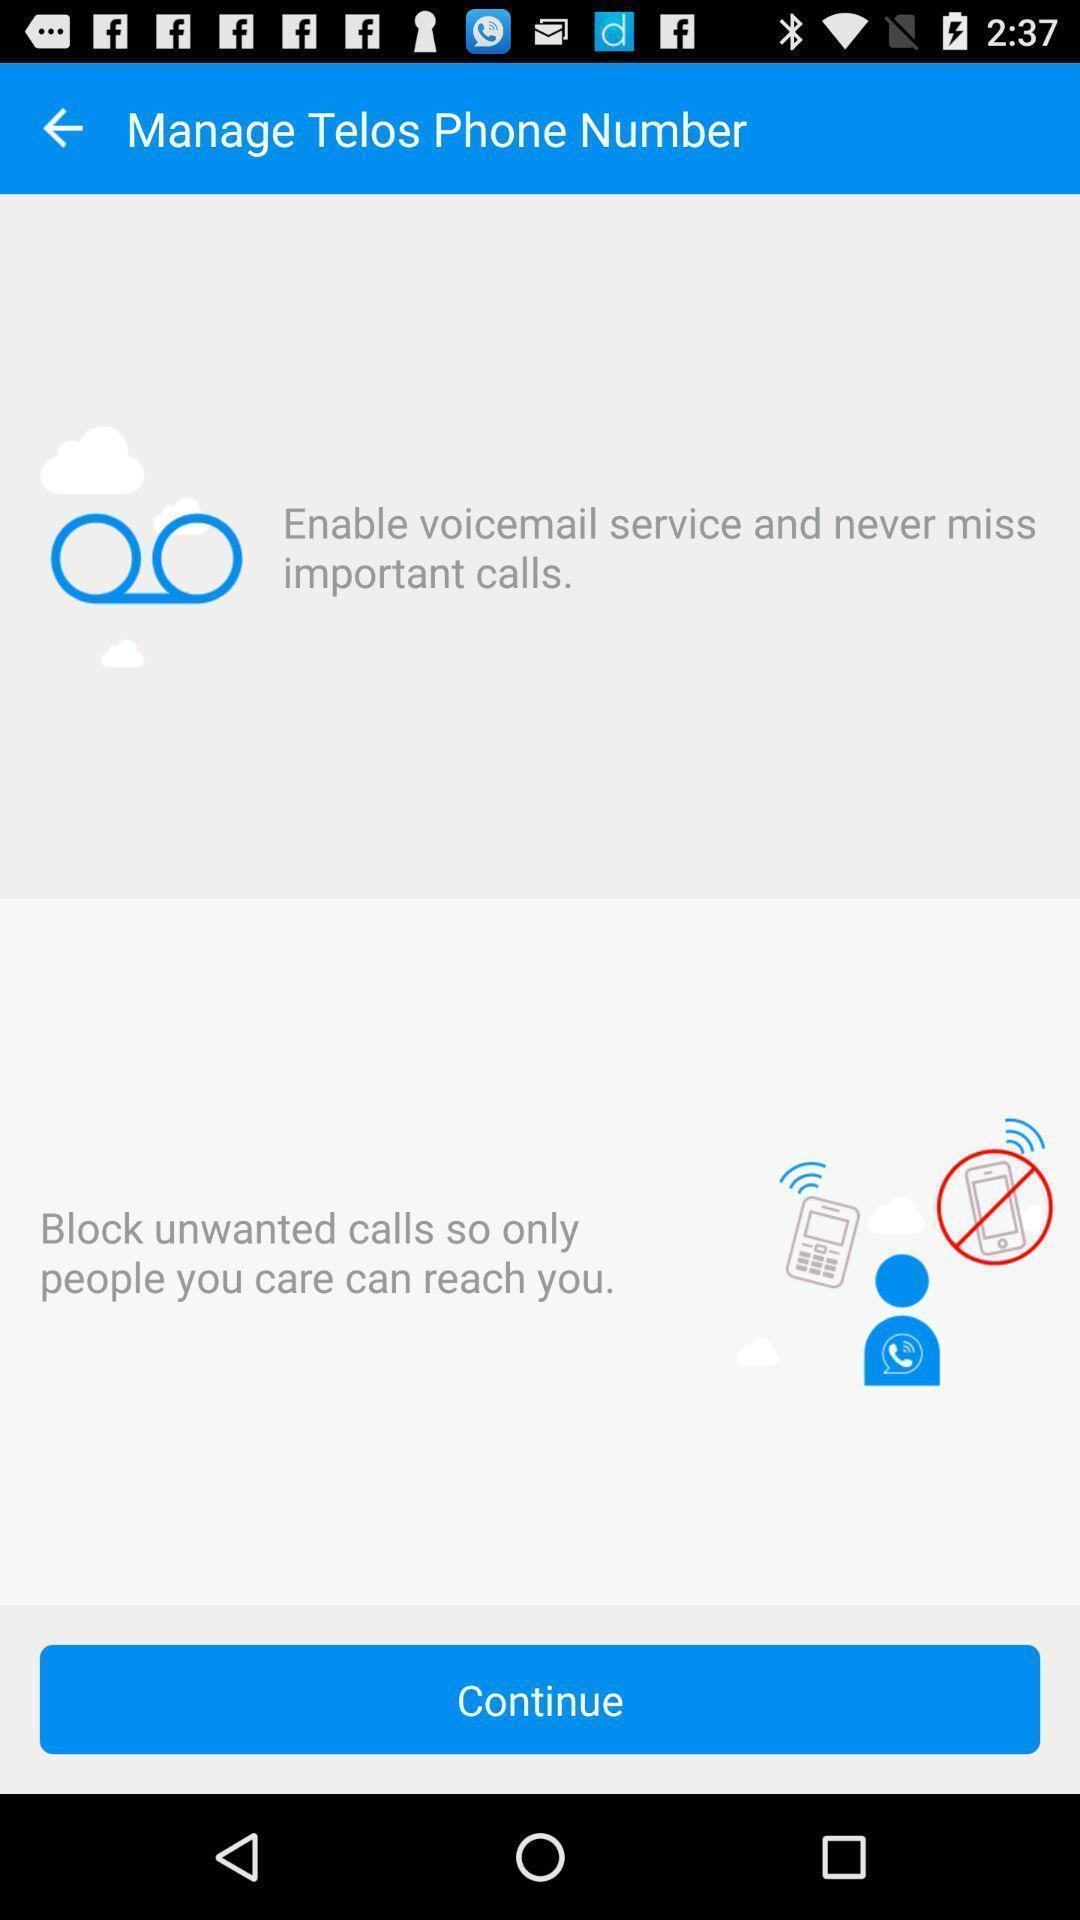Explain what's happening in this screen capture. Screen showing enable voicemail service. 